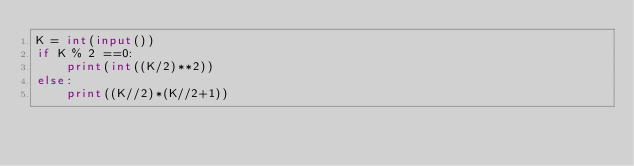<code> <loc_0><loc_0><loc_500><loc_500><_Python_>K = int(input())
if K % 2 ==0:
    print(int((K/2)**2))
else:
    print((K//2)*(K//2+1))</code> 